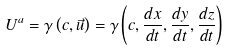Convert formula to latex. <formula><loc_0><loc_0><loc_500><loc_500>U ^ { a } = \gamma \left ( c , { \vec { u } } \right ) = \gamma \left ( c , { \frac { d x } { d t } } , { \frac { d y } { d t } } , { \frac { d z } { d t } } \right )</formula> 